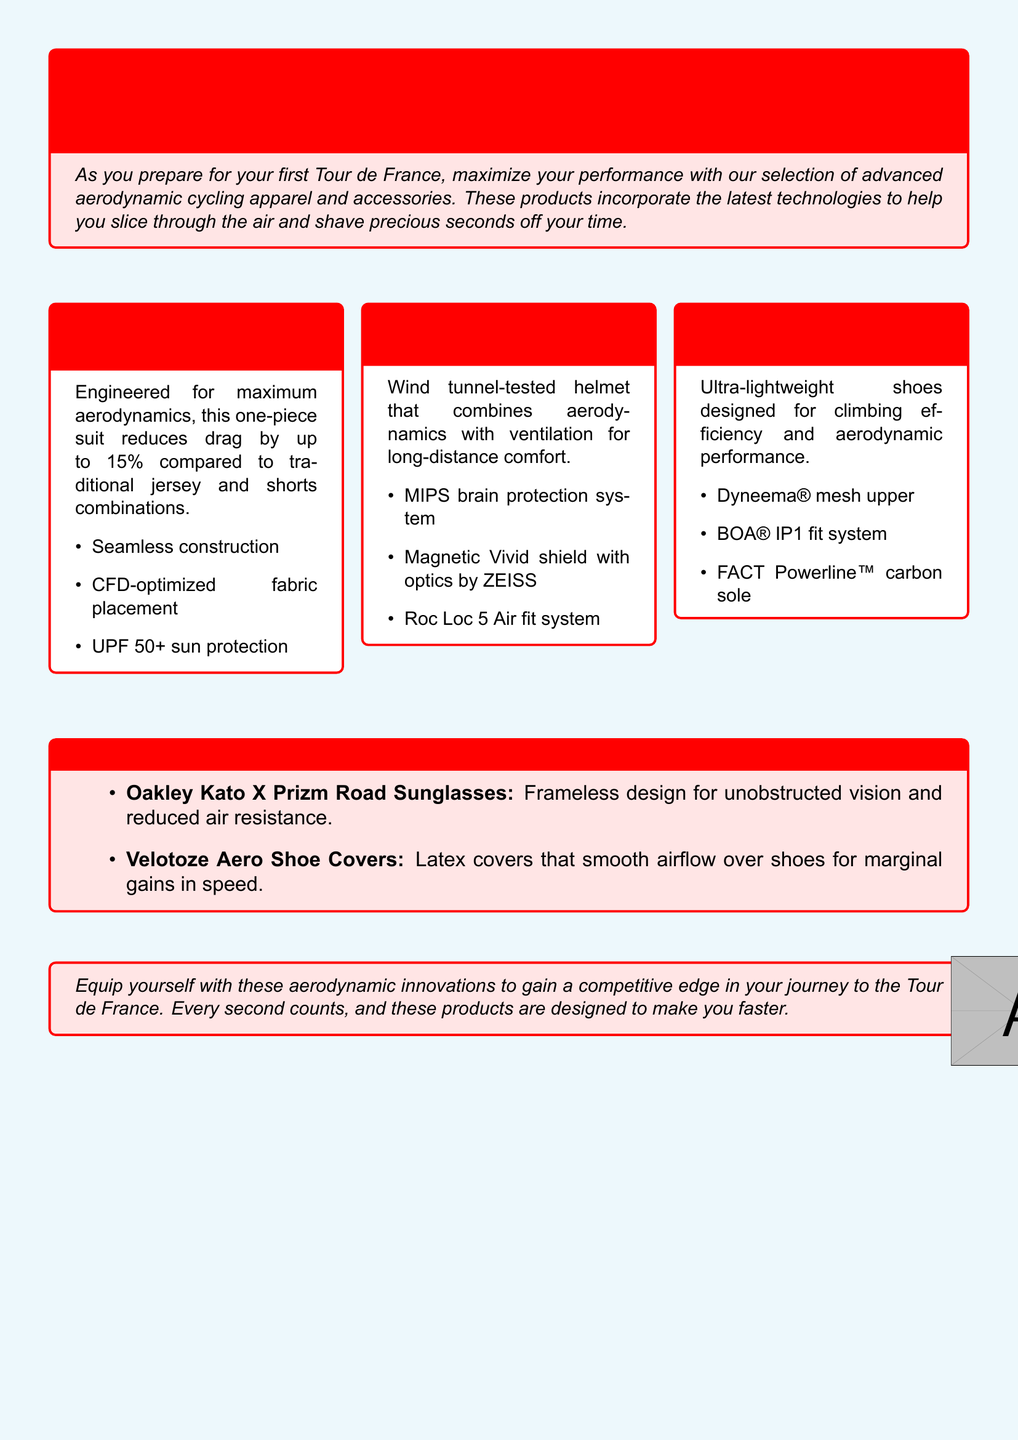What is the title of the catalog? The title of the catalog is listed prominently in the header of the document, emphasizing the focus on aerodynamic cycling gear.
Answer: Aero Advantage: Cutting-Edge Cycling Gear for Tour de France Aspirants Which product reduces drag by up to 15%? This information is specifically stated in the section describing the features of the Castelli Body Paint 4.X Speed Suit.
Answer: Castelli Body Paint 4.X Speed Suit What is the protection system in the Giro Aerohead MIPS Helmet? The document explicitly mentions the safety feature included in the helmet's design for enhanced brain protection.
Answer: MIPS brain protection system What type of fit system do the Specialized S-Works EXOS Road Shoes use? The fit system for the shoes is detailed in the product description, highlighting a specific brand used for adjustment.
Answer: BOA® IP1 fit system Which brand is associated with the sunglasses mentioned? The sunglasses are mentioned by name, identifying the brand known for its eyewear products in cycling.
Answer: Oakley What type of fabric is used in the construction of Specialized S-Works EXOS Road Shoes? The document indicates the specific material used in the shoes for optimal performance and lightweight design.
Answer: Dyneema® mesh Which accessory is designed to reduce air resistance for shoes? This accessory is listed under essential accessories, focusing specifically on its aerodynamic function.
Answer: Velotoze Aero Shoe Covers What is the unique feature of the Oakley Kato X Prizm Road Sunglasses? The document highlights a key design aspect of the sunglasses that enhances performance and minimizes drag.
Answer: Frameless design 